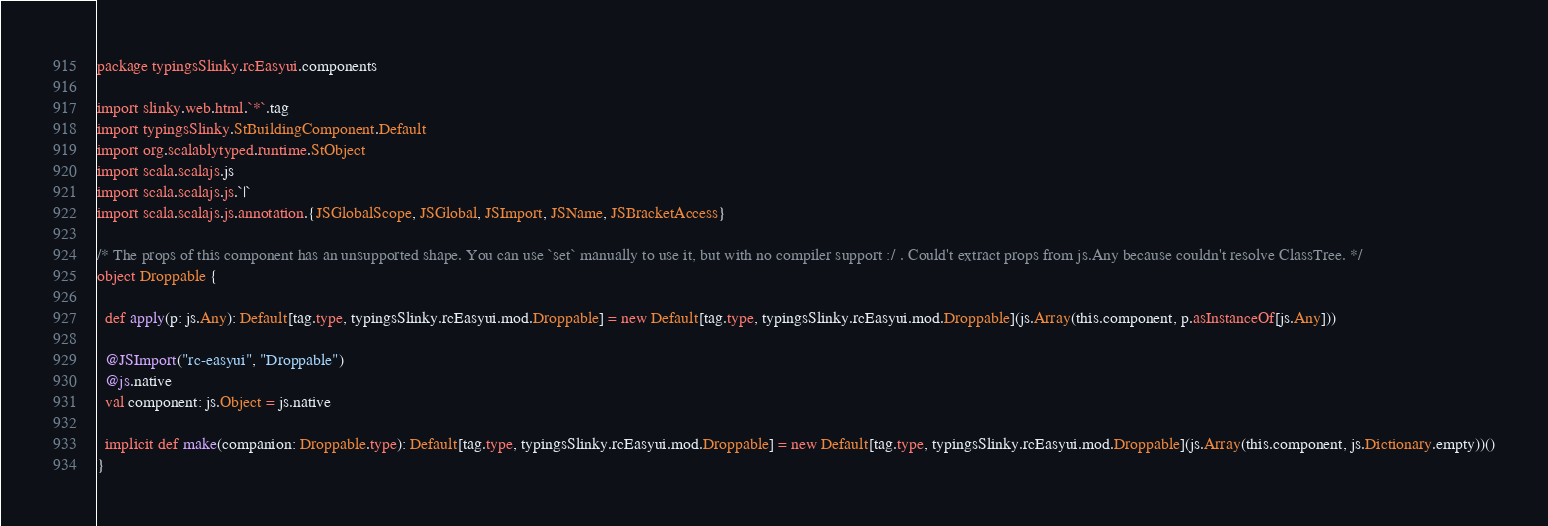Convert code to text. <code><loc_0><loc_0><loc_500><loc_500><_Scala_>package typingsSlinky.rcEasyui.components

import slinky.web.html.`*`.tag
import typingsSlinky.StBuildingComponent.Default
import org.scalablytyped.runtime.StObject
import scala.scalajs.js
import scala.scalajs.js.`|`
import scala.scalajs.js.annotation.{JSGlobalScope, JSGlobal, JSImport, JSName, JSBracketAccess}

/* The props of this component has an unsupported shape. You can use `set` manually to use it, but with no compiler support :/ . Could't extract props from js.Any because couldn't resolve ClassTree. */
object Droppable {
  
  def apply(p: js.Any): Default[tag.type, typingsSlinky.rcEasyui.mod.Droppable] = new Default[tag.type, typingsSlinky.rcEasyui.mod.Droppable](js.Array(this.component, p.asInstanceOf[js.Any]))
  
  @JSImport("rc-easyui", "Droppable")
  @js.native
  val component: js.Object = js.native
  
  implicit def make(companion: Droppable.type): Default[tag.type, typingsSlinky.rcEasyui.mod.Droppable] = new Default[tag.type, typingsSlinky.rcEasyui.mod.Droppable](js.Array(this.component, js.Dictionary.empty))()
}
</code> 